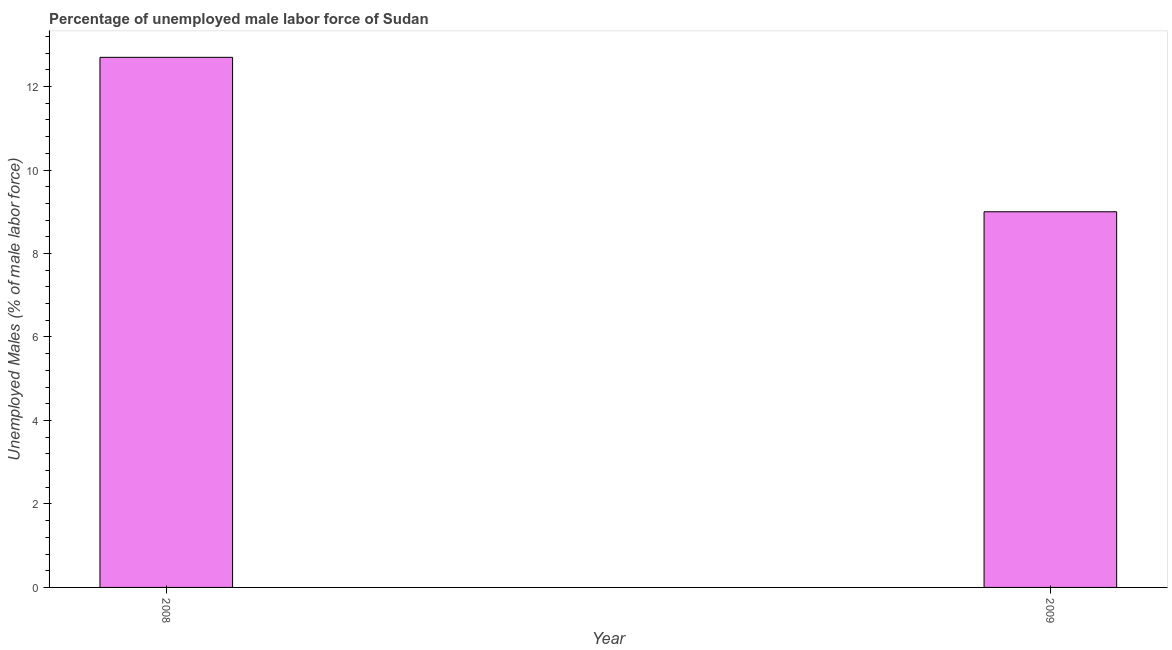What is the title of the graph?
Offer a terse response. Percentage of unemployed male labor force of Sudan. What is the label or title of the X-axis?
Keep it short and to the point. Year. What is the label or title of the Y-axis?
Make the answer very short. Unemployed Males (% of male labor force). What is the total unemployed male labour force in 2008?
Your response must be concise. 12.7. Across all years, what is the maximum total unemployed male labour force?
Your answer should be compact. 12.7. In which year was the total unemployed male labour force maximum?
Offer a very short reply. 2008. What is the sum of the total unemployed male labour force?
Your answer should be compact. 21.7. What is the difference between the total unemployed male labour force in 2008 and 2009?
Give a very brief answer. 3.7. What is the average total unemployed male labour force per year?
Your answer should be very brief. 10.85. What is the median total unemployed male labour force?
Provide a succinct answer. 10.85. In how many years, is the total unemployed male labour force greater than 10 %?
Offer a very short reply. 1. What is the ratio of the total unemployed male labour force in 2008 to that in 2009?
Offer a very short reply. 1.41. In how many years, is the total unemployed male labour force greater than the average total unemployed male labour force taken over all years?
Ensure brevity in your answer.  1. Are all the bars in the graph horizontal?
Your response must be concise. No. Are the values on the major ticks of Y-axis written in scientific E-notation?
Your answer should be very brief. No. What is the Unemployed Males (% of male labor force) of 2008?
Give a very brief answer. 12.7. What is the Unemployed Males (% of male labor force) in 2009?
Your response must be concise. 9. What is the difference between the Unemployed Males (% of male labor force) in 2008 and 2009?
Offer a very short reply. 3.7. What is the ratio of the Unemployed Males (% of male labor force) in 2008 to that in 2009?
Offer a terse response. 1.41. 